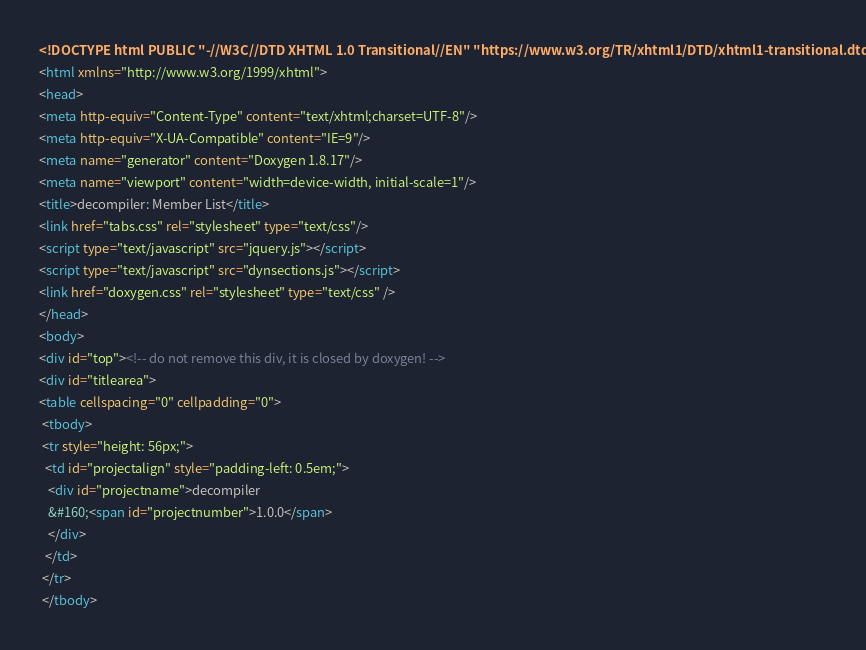<code> <loc_0><loc_0><loc_500><loc_500><_HTML_><!DOCTYPE html PUBLIC "-//W3C//DTD XHTML 1.0 Transitional//EN" "https://www.w3.org/TR/xhtml1/DTD/xhtml1-transitional.dtd">
<html xmlns="http://www.w3.org/1999/xhtml">
<head>
<meta http-equiv="Content-Type" content="text/xhtml;charset=UTF-8"/>
<meta http-equiv="X-UA-Compatible" content="IE=9"/>
<meta name="generator" content="Doxygen 1.8.17"/>
<meta name="viewport" content="width=device-width, initial-scale=1"/>
<title>decompiler: Member List</title>
<link href="tabs.css" rel="stylesheet" type="text/css"/>
<script type="text/javascript" src="jquery.js"></script>
<script type="text/javascript" src="dynsections.js"></script>
<link href="doxygen.css" rel="stylesheet" type="text/css" />
</head>
<body>
<div id="top"><!-- do not remove this div, it is closed by doxygen! -->
<div id="titlearea">
<table cellspacing="0" cellpadding="0">
 <tbody>
 <tr style="height: 56px;">
  <td id="projectalign" style="padding-left: 0.5em;">
   <div id="projectname">decompiler
   &#160;<span id="projectnumber">1.0.0</span>
   </div>
  </td>
 </tr>
 </tbody></code> 